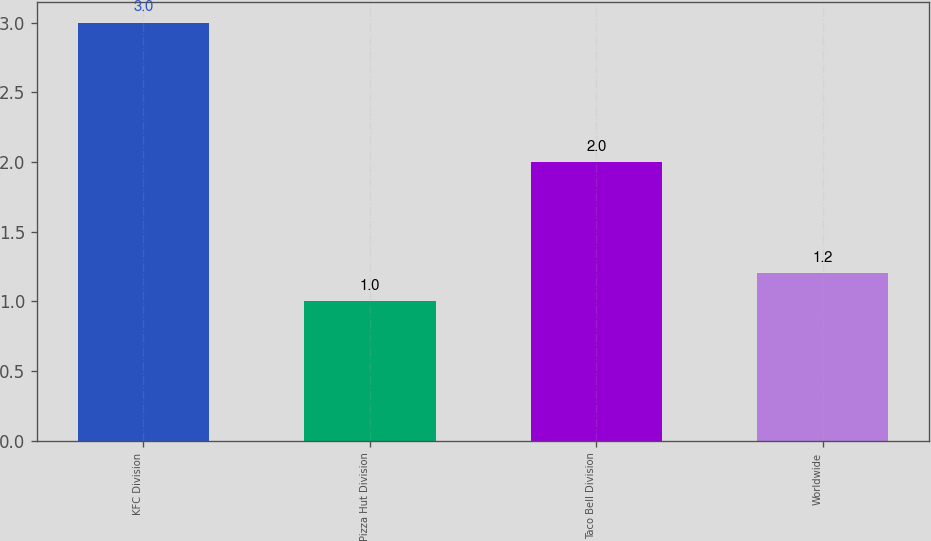<chart> <loc_0><loc_0><loc_500><loc_500><bar_chart><fcel>KFC Division<fcel>Pizza Hut Division<fcel>Taco Bell Division<fcel>Worldwide<nl><fcel>3<fcel>1<fcel>2<fcel>1.2<nl></chart> 